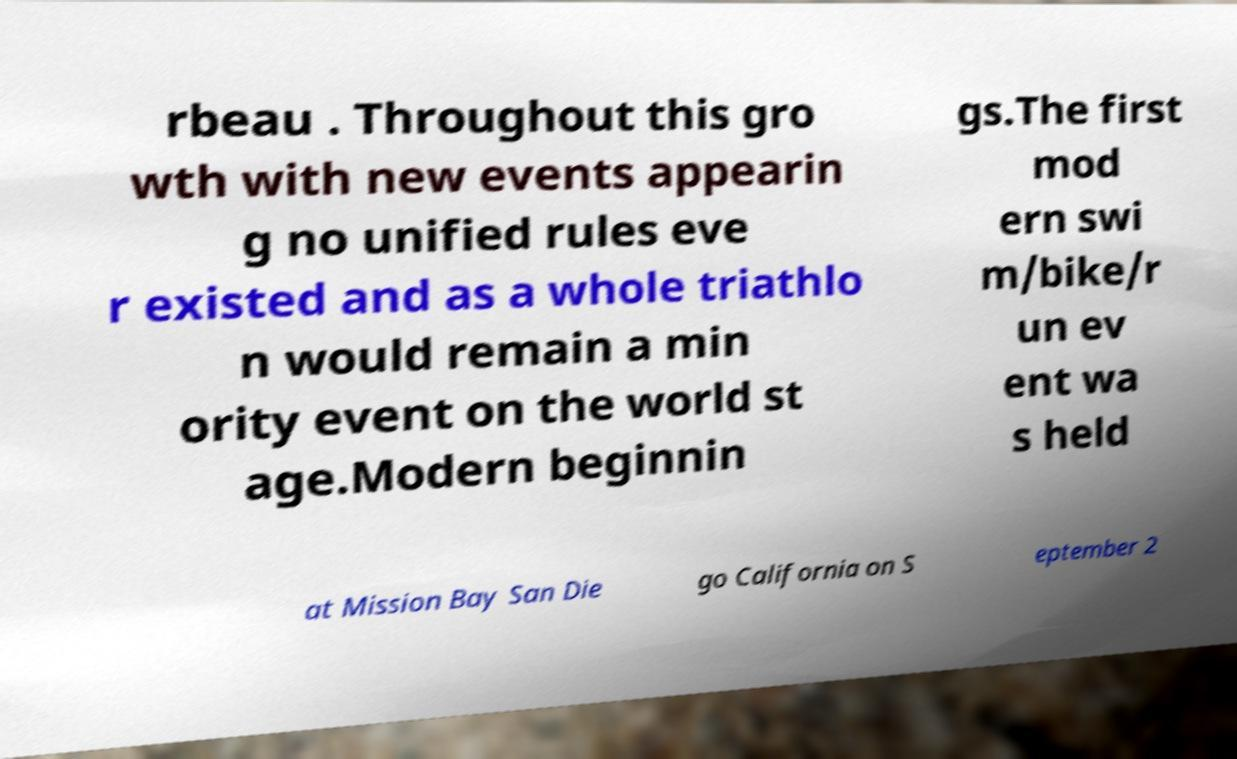For documentation purposes, I need the text within this image transcribed. Could you provide that? rbeau . Throughout this gro wth with new events appearin g no unified rules eve r existed and as a whole triathlo n would remain a min ority event on the world st age.Modern beginnin gs.The first mod ern swi m/bike/r un ev ent wa s held at Mission Bay San Die go California on S eptember 2 